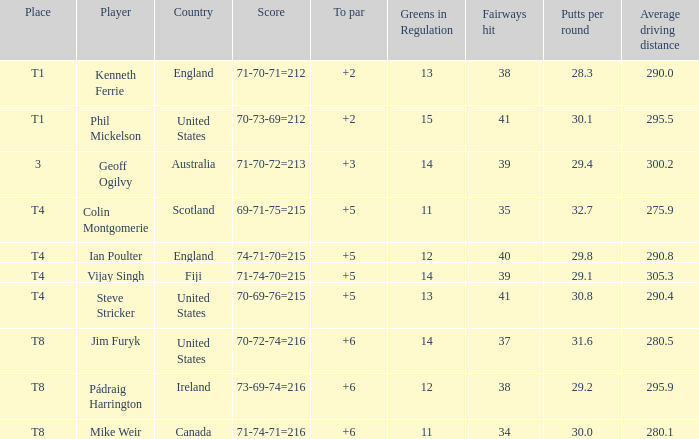What player was place of t1 in To Par and had a score of 70-73-69=212? 2.0. 